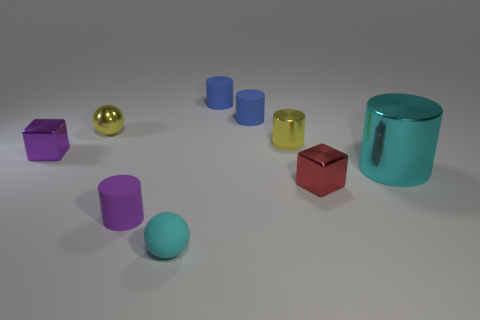Subtract all tiny purple cylinders. How many cylinders are left? 4 Subtract all purple cylinders. How many cylinders are left? 4 Subtract 3 cylinders. How many cylinders are left? 2 Subtract all red cylinders. Subtract all red balls. How many cylinders are left? 5 Add 1 metal objects. How many objects exist? 10 Subtract all cubes. How many objects are left? 7 Subtract 0 green cylinders. How many objects are left? 9 Subtract all small purple cylinders. Subtract all tiny metal cylinders. How many objects are left? 7 Add 8 red objects. How many red objects are left? 9 Add 3 yellow objects. How many yellow objects exist? 5 